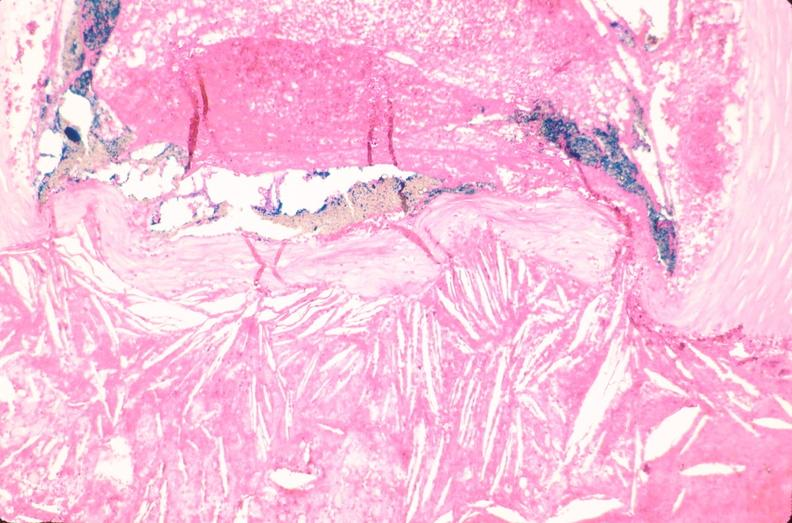does conjoined twins show coronary artery atherosclerosis?
Answer the question using a single word or phrase. No 